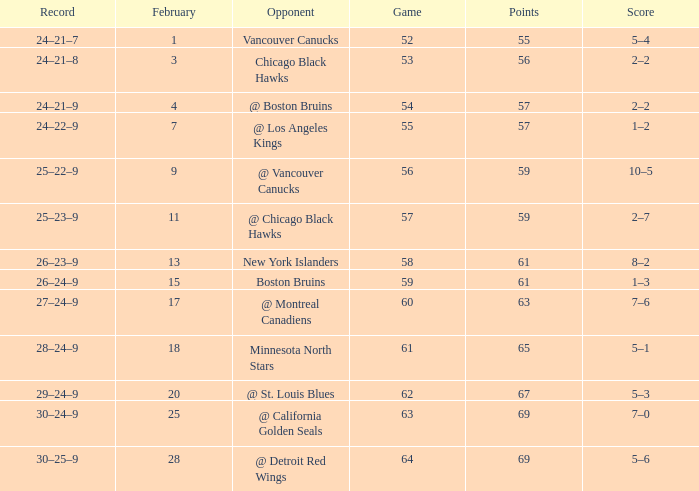How many games have a record of 30–25–9 and more points than 69? 0.0. 